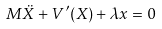Convert formula to latex. <formula><loc_0><loc_0><loc_500><loc_500>M \ddot { X } + V ^ { \prime } ( X ) + \lambda x = 0</formula> 